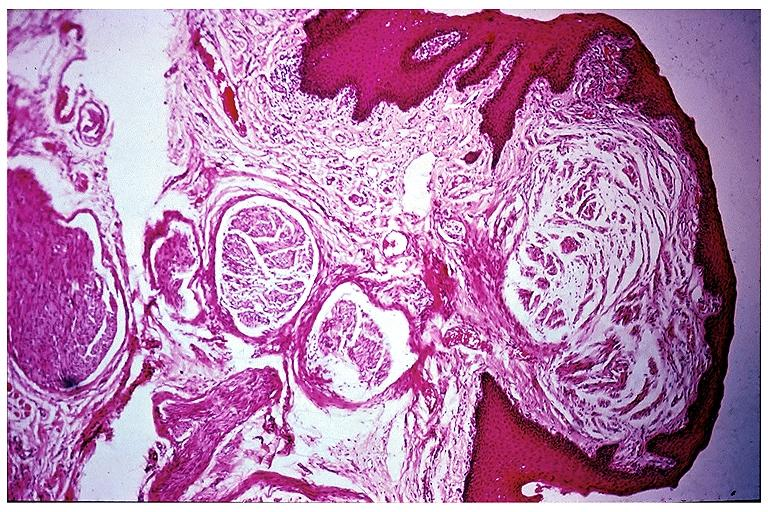where is this?
Answer the question using a single word or phrase. Oral 